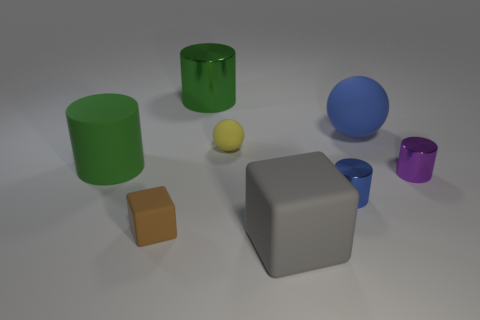The large green object that is the same material as the small yellow sphere is what shape?
Your response must be concise. Cylinder. Is there a cylinder that has the same color as the large shiny thing?
Give a very brief answer. Yes. What is the material of the purple cylinder?
Make the answer very short. Metal. How many things are large green rubber cylinders or small balls?
Your answer should be very brief. 2. There is a green cylinder left of the brown object; how big is it?
Offer a terse response. Large. What number of other objects are the same material as the brown cube?
Ensure brevity in your answer.  4. Are there any yellow spheres in front of the tiny rubber thing that is in front of the large green rubber thing?
Offer a terse response. No. Is there anything else that is the same shape as the tiny yellow matte thing?
Make the answer very short. Yes. There is another small object that is the same shape as the blue matte thing; what is its color?
Your response must be concise. Yellow. The purple cylinder has what size?
Keep it short and to the point. Small. 